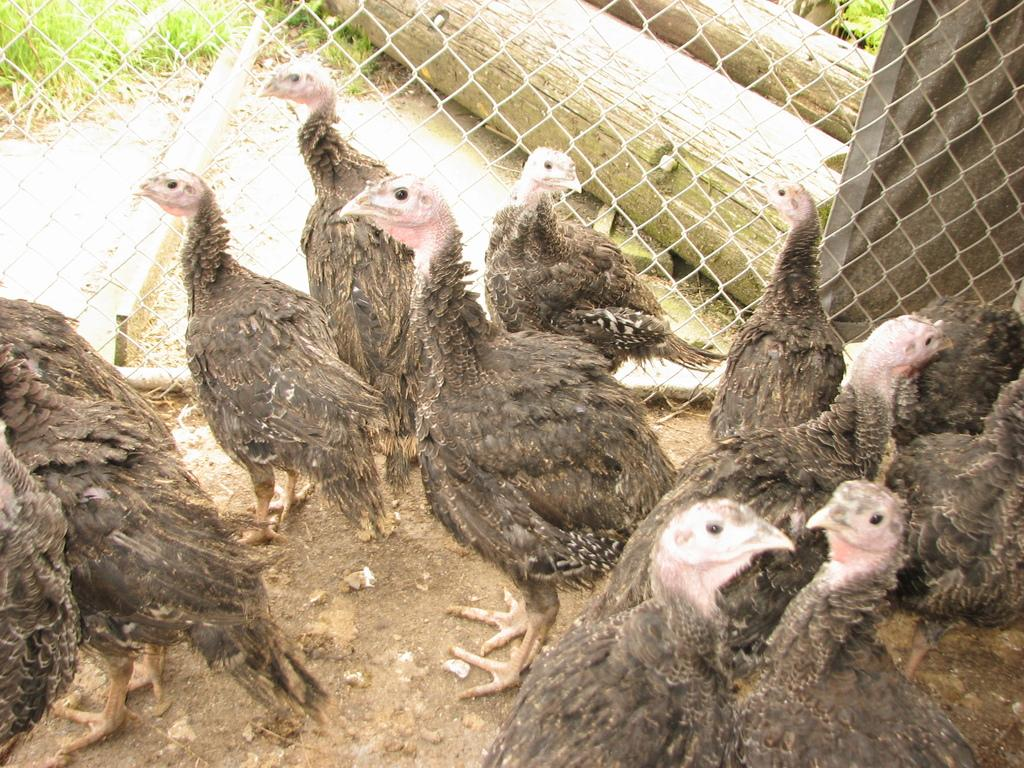What type of animals are in the foreground of the image? There are hens in the foreground of the image. What is located behind the hens? There is fencing behind the hens. What is behind the fencing? There is a metal sheet behind the fencing. What can be seen behind the metal sheet? Grass is visible behind the metal sheet. What type of vegetation is present in the background of the image? Wooden trunks are present in the background of the image. How many cacti can be seen in the image? There are no cacti present in the image. Can you describe the cow's behavior in the image? There is no cow present in the image. 